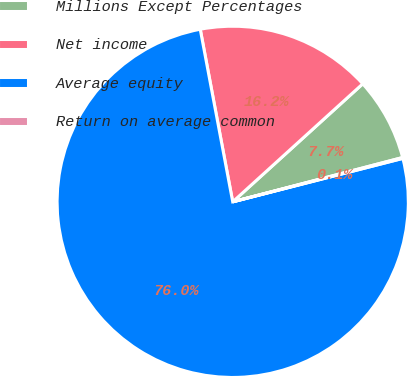<chart> <loc_0><loc_0><loc_500><loc_500><pie_chart><fcel>Millions Except Percentages<fcel>Net income<fcel>Average equity<fcel>Return on average common<nl><fcel>7.67%<fcel>16.23%<fcel>76.02%<fcel>0.08%<nl></chart> 